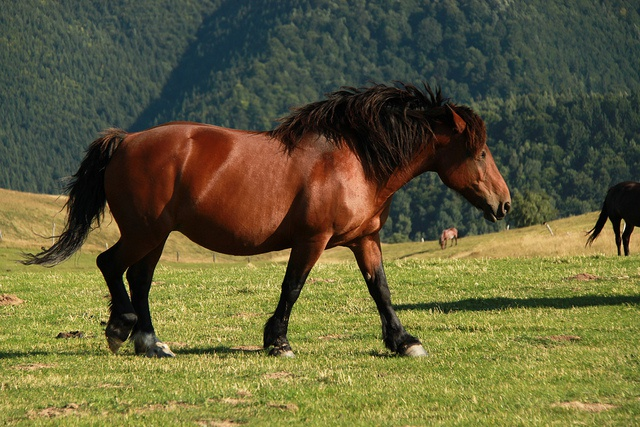Describe the objects in this image and their specific colors. I can see horse in gray, black, maroon, brown, and red tones, horse in gray, black, tan, olive, and maroon tones, and horse in gray, olive, and tan tones in this image. 